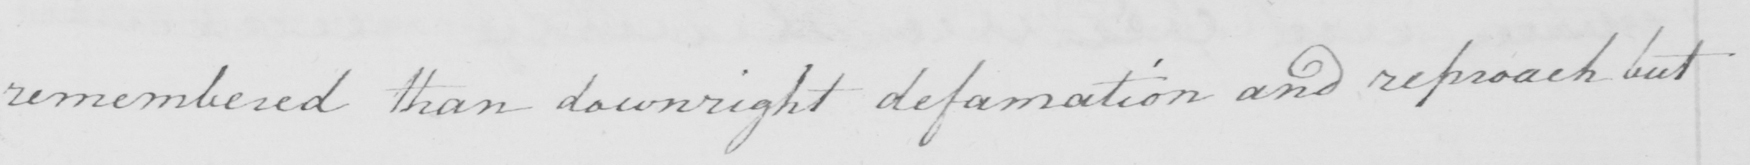What text is written in this handwritten line? remembered than downright defamation and reproach but 